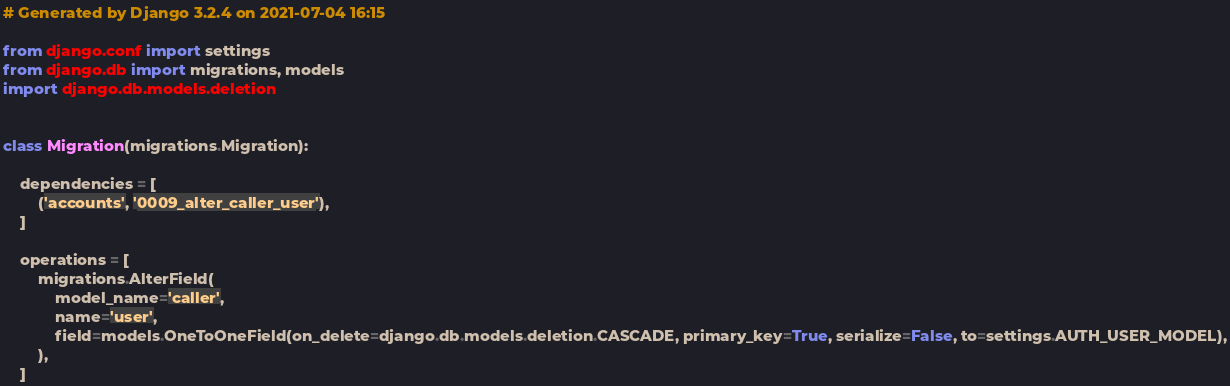<code> <loc_0><loc_0><loc_500><loc_500><_Python_># Generated by Django 3.2.4 on 2021-07-04 16:15

from django.conf import settings
from django.db import migrations, models
import django.db.models.deletion


class Migration(migrations.Migration):

    dependencies = [
        ('accounts', '0009_alter_caller_user'),
    ]

    operations = [
        migrations.AlterField(
            model_name='caller',
            name='user',
            field=models.OneToOneField(on_delete=django.db.models.deletion.CASCADE, primary_key=True, serialize=False, to=settings.AUTH_USER_MODEL),
        ),
    ]
</code> 